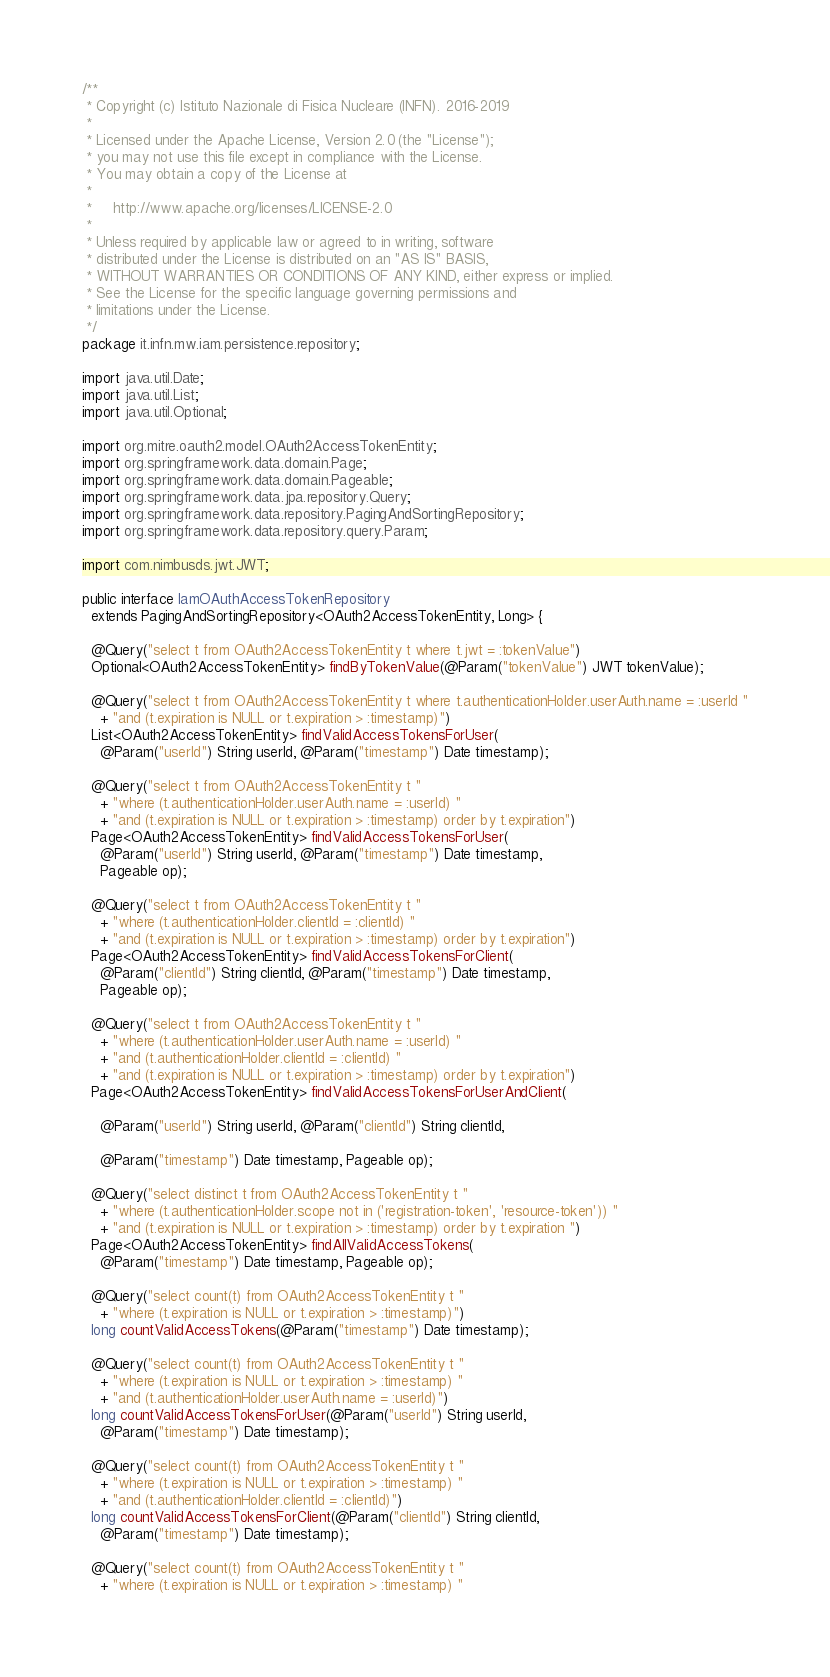Convert code to text. <code><loc_0><loc_0><loc_500><loc_500><_Java_>/**
 * Copyright (c) Istituto Nazionale di Fisica Nucleare (INFN). 2016-2019
 *
 * Licensed under the Apache License, Version 2.0 (the "License");
 * you may not use this file except in compliance with the License.
 * You may obtain a copy of the License at
 *
 *     http://www.apache.org/licenses/LICENSE-2.0
 *
 * Unless required by applicable law or agreed to in writing, software
 * distributed under the License is distributed on an "AS IS" BASIS,
 * WITHOUT WARRANTIES OR CONDITIONS OF ANY KIND, either express or implied.
 * See the License for the specific language governing permissions and
 * limitations under the License.
 */
package it.infn.mw.iam.persistence.repository;

import java.util.Date;
import java.util.List;
import java.util.Optional;

import org.mitre.oauth2.model.OAuth2AccessTokenEntity;
import org.springframework.data.domain.Page;
import org.springframework.data.domain.Pageable;
import org.springframework.data.jpa.repository.Query;
import org.springframework.data.repository.PagingAndSortingRepository;
import org.springframework.data.repository.query.Param;

import com.nimbusds.jwt.JWT;

public interface IamOAuthAccessTokenRepository
  extends PagingAndSortingRepository<OAuth2AccessTokenEntity, Long> {
  
  @Query("select t from OAuth2AccessTokenEntity t where t.jwt = :tokenValue")
  Optional<OAuth2AccessTokenEntity> findByTokenValue(@Param("tokenValue") JWT tokenValue);

  @Query("select t from OAuth2AccessTokenEntity t where t.authenticationHolder.userAuth.name = :userId "
    + "and (t.expiration is NULL or t.expiration > :timestamp)")
  List<OAuth2AccessTokenEntity> findValidAccessTokensForUser(
    @Param("userId") String userId, @Param("timestamp") Date timestamp);

  @Query("select t from OAuth2AccessTokenEntity t "
    + "where (t.authenticationHolder.userAuth.name = :userId) "
    + "and (t.expiration is NULL or t.expiration > :timestamp) order by t.expiration")
  Page<OAuth2AccessTokenEntity> findValidAccessTokensForUser(
    @Param("userId") String userId, @Param("timestamp") Date timestamp,
    Pageable op);

  @Query("select t from OAuth2AccessTokenEntity t "
    + "where (t.authenticationHolder.clientId = :clientId) "
    + "and (t.expiration is NULL or t.expiration > :timestamp) order by t.expiration")
  Page<OAuth2AccessTokenEntity> findValidAccessTokensForClient(
    @Param("clientId") String clientId, @Param("timestamp") Date timestamp,
    Pageable op);

  @Query("select t from OAuth2AccessTokenEntity t "
    + "where (t.authenticationHolder.userAuth.name = :userId) "
    + "and (t.authenticationHolder.clientId = :clientId) "
    + "and (t.expiration is NULL or t.expiration > :timestamp) order by t.expiration")
  Page<OAuth2AccessTokenEntity> findValidAccessTokensForUserAndClient(

    @Param("userId") String userId, @Param("clientId") String clientId,

    @Param("timestamp") Date timestamp, Pageable op);

  @Query("select distinct t from OAuth2AccessTokenEntity t "
    + "where (t.authenticationHolder.scope not in ('registration-token', 'resource-token')) "
    + "and (t.expiration is NULL or t.expiration > :timestamp) order by t.expiration ")
  Page<OAuth2AccessTokenEntity> findAllValidAccessTokens(
    @Param("timestamp") Date timestamp, Pageable op);

  @Query("select count(t) from OAuth2AccessTokenEntity t "
    + "where (t.expiration is NULL or t.expiration > :timestamp)")
  long countValidAccessTokens(@Param("timestamp") Date timestamp);

  @Query("select count(t) from OAuth2AccessTokenEntity t "
    + "where (t.expiration is NULL or t.expiration > :timestamp) "
    + "and (t.authenticationHolder.userAuth.name = :userId)")
  long countValidAccessTokensForUser(@Param("userId") String userId,
    @Param("timestamp") Date timestamp);

  @Query("select count(t) from OAuth2AccessTokenEntity t "
    + "where (t.expiration is NULL or t.expiration > :timestamp) "
    + "and (t.authenticationHolder.clientId = :clientId)")
  long countValidAccessTokensForClient(@Param("clientId") String clientId,
    @Param("timestamp") Date timestamp);

  @Query("select count(t) from OAuth2AccessTokenEntity t "
    + "where (t.expiration is NULL or t.expiration > :timestamp) "</code> 